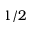<formula> <loc_0><loc_0><loc_500><loc_500>1 / 2</formula> 